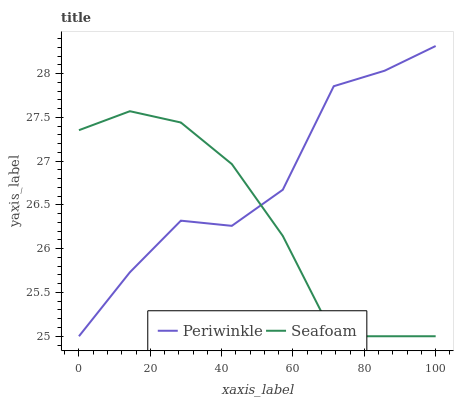Does Seafoam have the minimum area under the curve?
Answer yes or no. Yes. Does Periwinkle have the maximum area under the curve?
Answer yes or no. Yes. Does Seafoam have the maximum area under the curve?
Answer yes or no. No. Is Seafoam the smoothest?
Answer yes or no. Yes. Is Periwinkle the roughest?
Answer yes or no. Yes. Is Seafoam the roughest?
Answer yes or no. No. Does Periwinkle have the highest value?
Answer yes or no. Yes. Does Seafoam have the highest value?
Answer yes or no. No. 